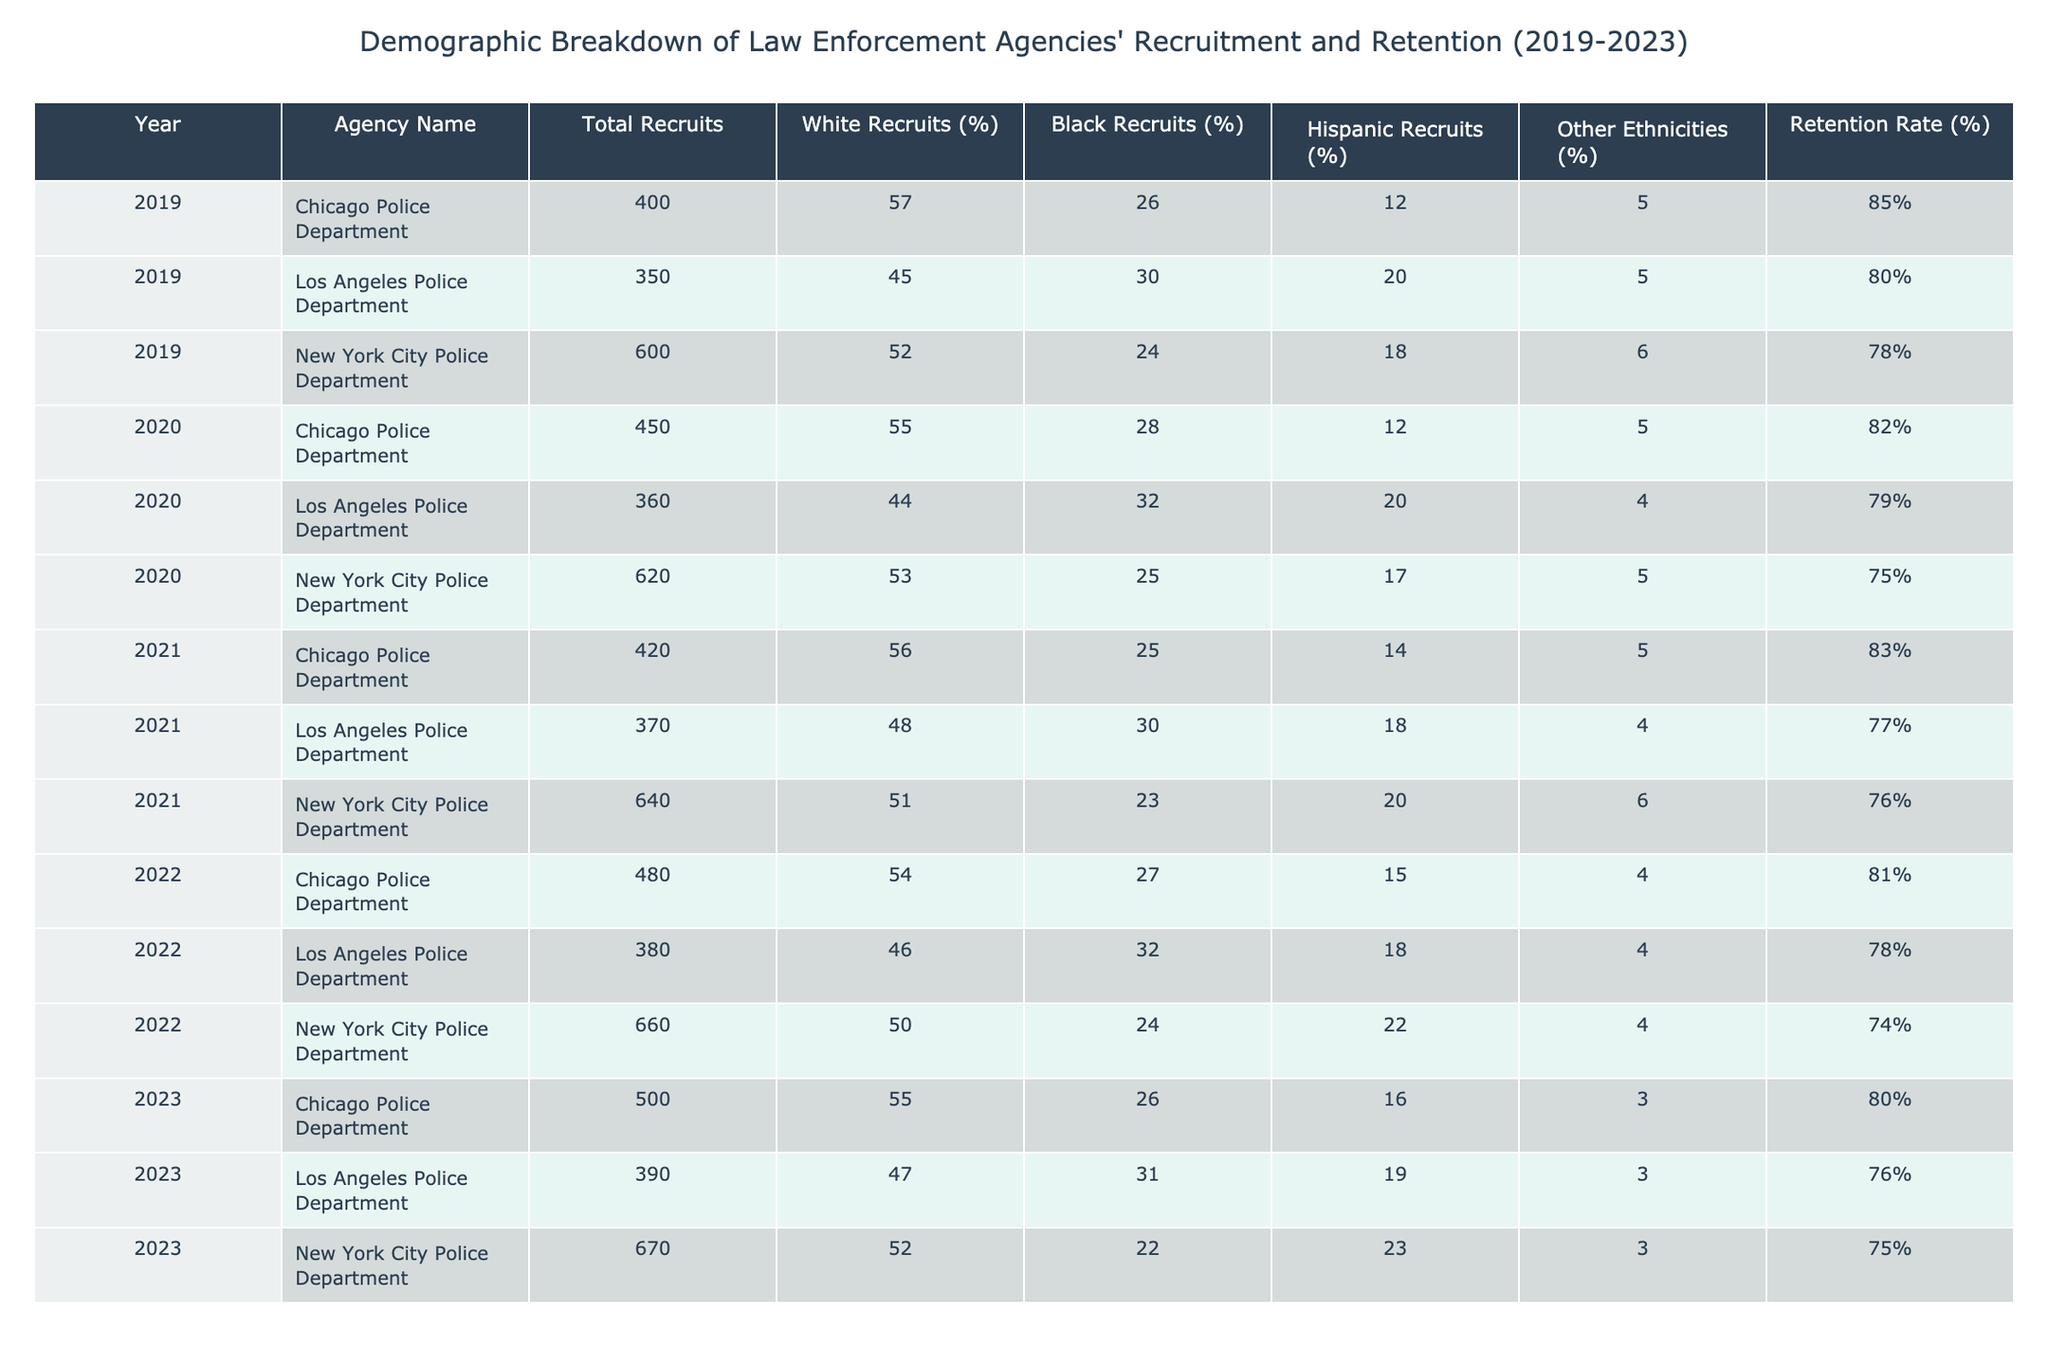What was the retention rate for the Los Angeles Police Department in 2022? The table shows that the retention rate for the Los Angeles Police Department in 2022 is listed as 78%.
Answer: 78% Which agency had the highest total recruits in 2023? From the table, the New York City Police Department had the highest number of total recruits in 2023 with 670 recruits.
Answer: New York City Police Department What is the percentage of Black recruits for the Chicago Police Department in 2021? According to the table, the percentage of Black recruits for the Chicago Police Department in 2021 is 25%.
Answer: 25% What was the average retention rate for all three agencies over the five years? To find the average retention rate, add all the retention rates (85 + 80 + 78 + 82 + 79 + 75 + 83 + 77 + 76 + 81 + 78 + 74 + 80 + 76 + 75 = 1180) and divide by the number of data points (15). The average retention rate is 1180 / 15 = 78.67%, which can be rounded to 79%.
Answer: 79% Did the percentage of Hispanic recruits for the Los Angeles Police Department increase from 2019 to 2023? Looking at the table, the percentage of Hispanic recruits for the Los Angeles Police Department in 2019 is 20%, and in 2023 it is 19%. Therefore, it decreased over the years.
Answer: No Which agency had the lowest percentage of White recruits in 2020? In 2020, the agency with the lowest percentage of White recruits is the Los Angeles Police Department with 44%.
Answer: Los Angeles Police Department What was the change in total recruits for the Chicago Police Department from 2019 to 2023? The total recruits for the Chicago Police Department in 2019 were 400, and in 2023, it was 500. The change can be calculated as 500 - 400 = 100.
Answer: 100 Which year showed the highest percentage of Other Ethnicities in the recruitment for the New York City Police Department? By reviewing the table, in 2022, the percentage of Other Ethnicities for the New York City Police Department is 4%, which is the highest throughout the years shown.
Answer: 4% 